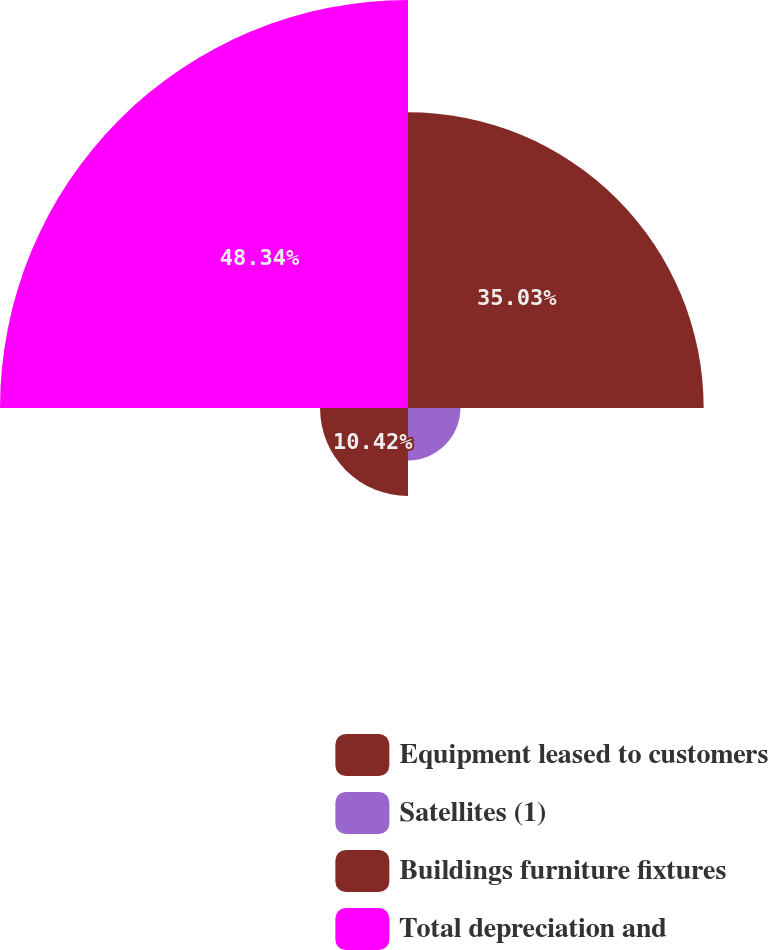<chart> <loc_0><loc_0><loc_500><loc_500><pie_chart><fcel>Equipment leased to customers<fcel>Satellites (1)<fcel>Buildings furniture fixtures<fcel>Total depreciation and<nl><fcel>35.03%<fcel>6.21%<fcel>10.42%<fcel>48.34%<nl></chart> 